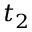Convert formula to latex. <formula><loc_0><loc_0><loc_500><loc_500>t _ { 2 }</formula> 